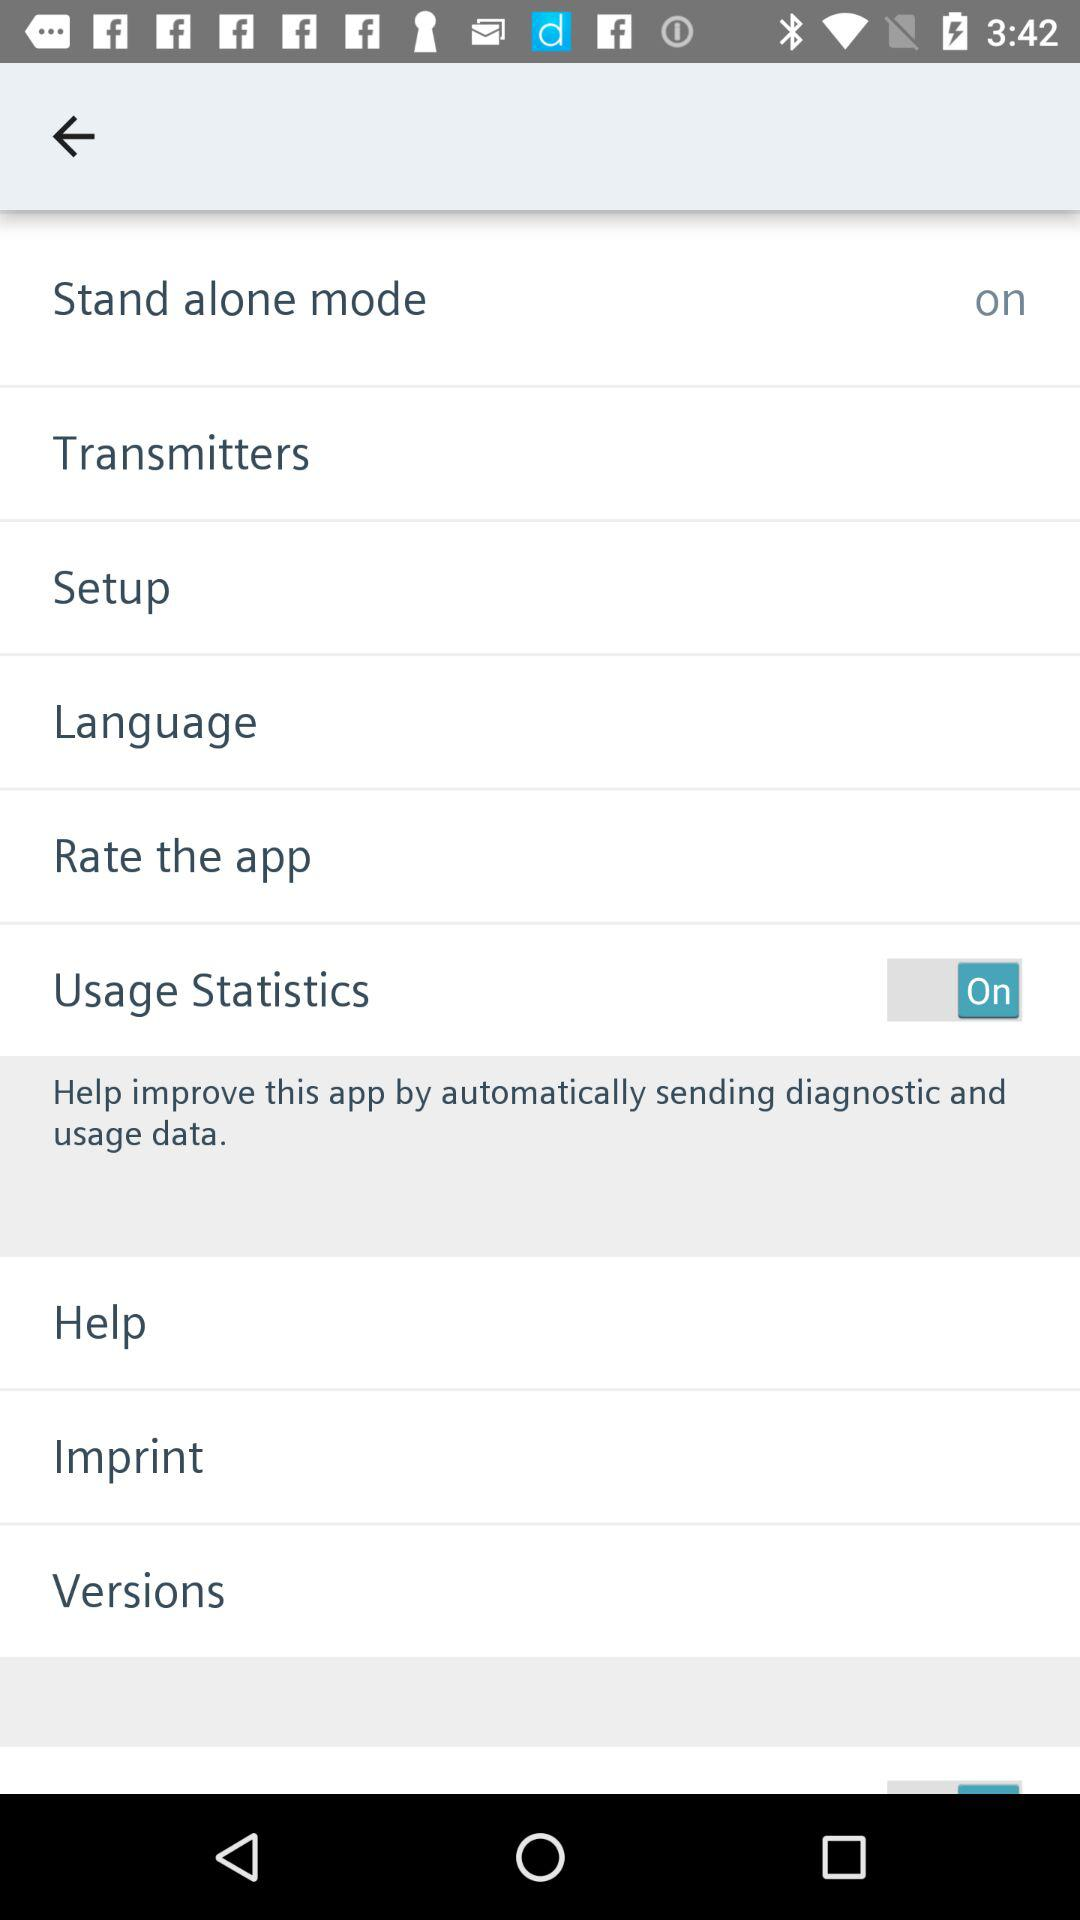What is the status of "Usage Statistics"? The status is "on". 